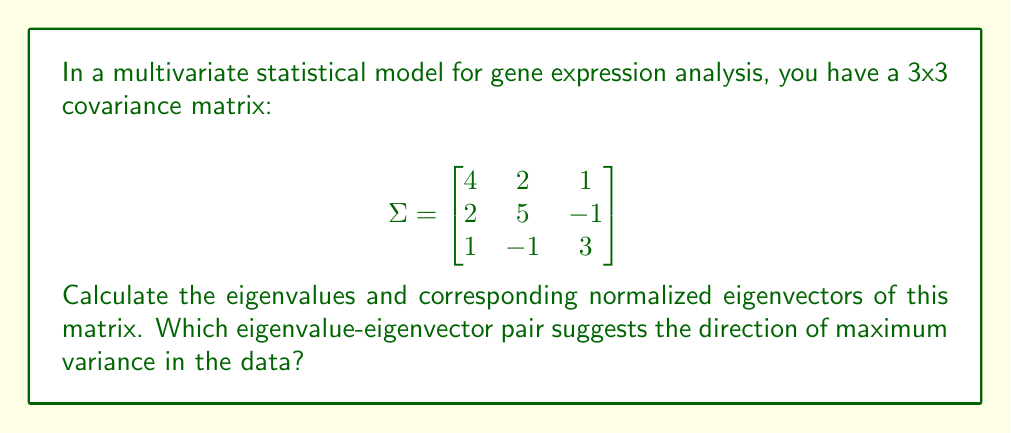Can you solve this math problem? To find the eigenvalues and eigenvectors of the covariance matrix $\Sigma$, we follow these steps:

1) Find the eigenvalues by solving the characteristic equation:
   $\det(\Sigma - \lambda I) = 0$

   $$\begin{vmatrix}
   4-\lambda & 2 & 1 \\
   2 & 5-\lambda & -1 \\
   1 & -1 & 3-\lambda
   \end{vmatrix} = 0$$

2) Expanding the determinant:
   $(4-\lambda)((5-\lambda)(3-\lambda)+1) - 2(2(3-\lambda)-1) + 1(2(-1)-(5-\lambda)) = 0$
   
   $-\lambda^3 + 12\lambda^2 - 44\lambda + 48 = 0$

3) Solving this cubic equation (using a calculator or computer algebra system) gives:
   $\lambda_1 = 6.37228, \lambda_2 = 3.94085, \lambda_3 = 1.68687$

4) For each eigenvalue, find the corresponding eigenvector by solving:
   $(\Sigma - \lambda_i I)\mathbf{v}_i = \mathbf{0}$

5) For $\lambda_1 = 6.37228$:
   $$\begin{bmatrix}
   -2.37228 & 2 & 1 \\
   2 & -1.37228 & -1 \\
   1 & -1 & -3.37228
   \end{bmatrix}\mathbf{v}_1 = \mathbf{0}$$

   Solving this gives (unnormalized): $\mathbf{v}_1 \approx (0.6614, 0.7040, 0.2589)$

6) Normalizing $\mathbf{v}_1$:
   $\mathbf{v}_1 \approx (0.6748, 0.7183, 0.2642)$

7) Similarly, for $\lambda_2$ and $\lambda_3$:
   $\mathbf{v}_2 \approx (-0.2912, 0.6326, -0.7177)$
   $\mathbf{v}_3 \approx (0.6778, -0.2900, -0.6752)$

8) The eigenvalue-eigenvector pair with the largest eigenvalue ($\lambda_1 = 6.37228$) corresponds to the direction of maximum variance in the data.
Answer: Eigenvalues: $\lambda_1 \approx 6.37228, \lambda_2 \approx 3.94085, \lambda_3 \approx 1.68687$
Normalized eigenvectors:
$\mathbf{v}_1 \approx (0.6748, 0.7183, 0.2642)$
$\mathbf{v}_2 \approx (-0.2912, 0.6326, -0.7177)$
$\mathbf{v}_3 \approx (0.6778, -0.2900, -0.6752)$
Maximum variance direction: $\mathbf{v}_1$ 